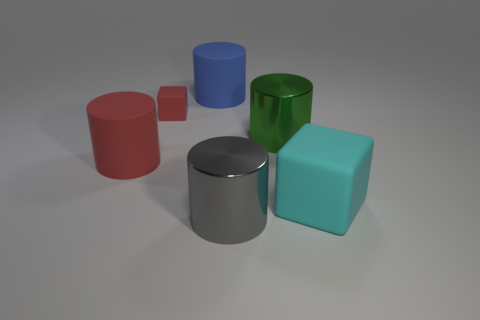Do the cyan matte object and the small red matte thing have the same shape?
Offer a terse response. Yes. How many objects are in front of the tiny thing and on the left side of the green object?
Your answer should be compact. 2. How many matte objects are tiny green cubes or small red objects?
Offer a terse response. 1. There is a block that is behind the large matte thing to the right of the big green cylinder; what size is it?
Give a very brief answer. Small. There is a large object that is on the left side of the rubber cube left of the large green metallic cylinder; are there any blocks behind it?
Provide a succinct answer. Yes. Do the thing that is on the right side of the big green thing and the large object that is behind the small red matte thing have the same material?
Your answer should be compact. Yes. What number of objects are red metal cylinders or big rubber objects that are left of the gray cylinder?
Your answer should be compact. 2. How many tiny rubber objects have the same shape as the large green shiny object?
Give a very brief answer. 0. There is a gray object that is the same size as the cyan thing; what is its material?
Make the answer very short. Metal. There is a matte block behind the large matte object to the right of the rubber cylinder that is behind the small matte thing; what is its size?
Give a very brief answer. Small. 